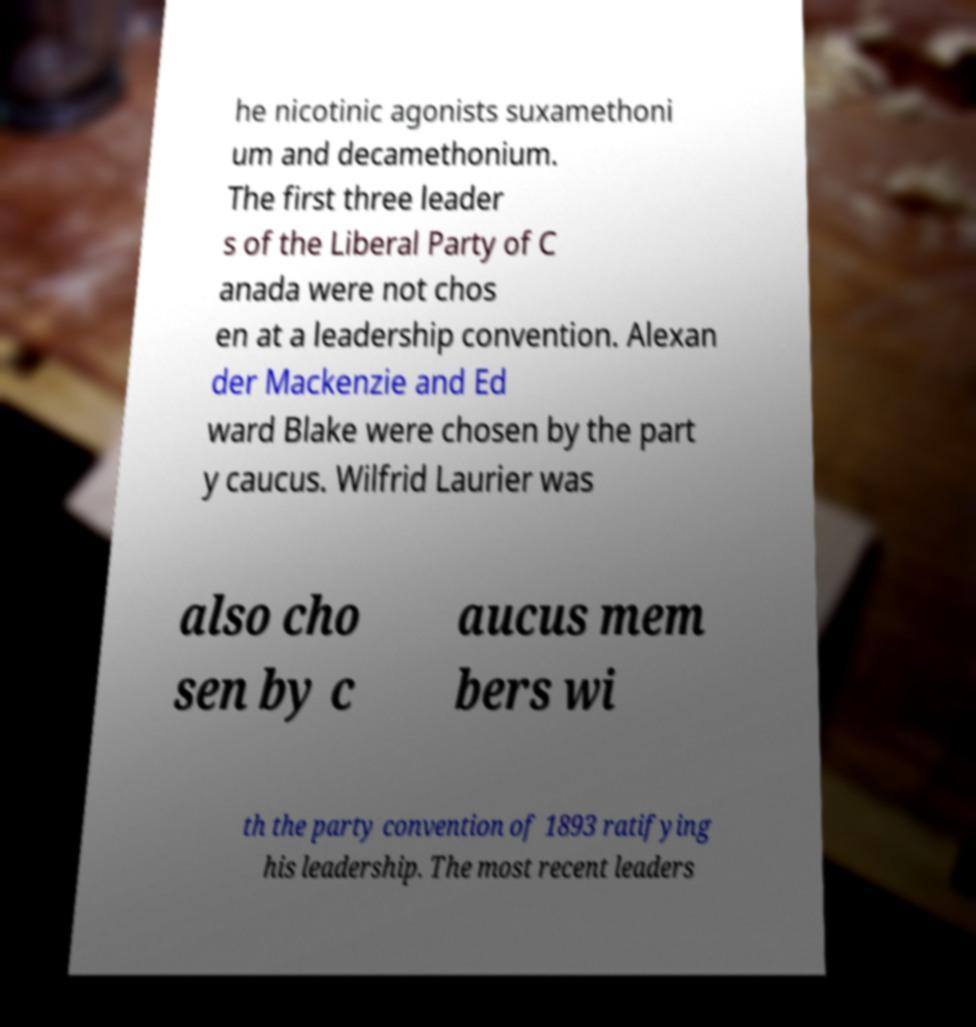What messages or text are displayed in this image? I need them in a readable, typed format. he nicotinic agonists suxamethoni um and decamethonium. The first three leader s of the Liberal Party of C anada were not chos en at a leadership convention. Alexan der Mackenzie and Ed ward Blake were chosen by the part y caucus. Wilfrid Laurier was also cho sen by c aucus mem bers wi th the party convention of 1893 ratifying his leadership. The most recent leaders 